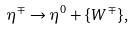<formula> <loc_0><loc_0><loc_500><loc_500>\eta ^ { \mp } \to \eta ^ { 0 } + \{ W ^ { \mp } \} ,</formula> 